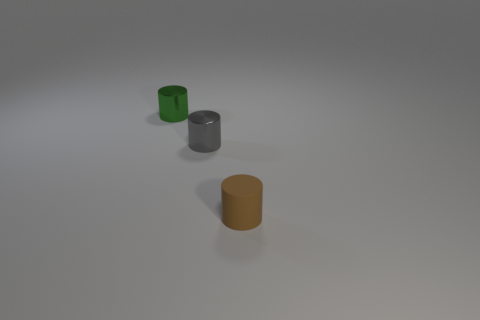Subtract all small brown cylinders. How many cylinders are left? 2 Subtract 1 green cylinders. How many objects are left? 2 Subtract 2 cylinders. How many cylinders are left? 1 Subtract all gray cylinders. Subtract all brown blocks. How many cylinders are left? 2 Subtract all green cubes. How many yellow cylinders are left? 0 Subtract all tiny red metallic cubes. Subtract all small brown matte cylinders. How many objects are left? 2 Add 1 small green metal cylinders. How many small green metal cylinders are left? 2 Add 3 small metal cylinders. How many small metal cylinders exist? 5 Add 3 tiny green metal cylinders. How many objects exist? 6 Subtract all gray cylinders. How many cylinders are left? 2 